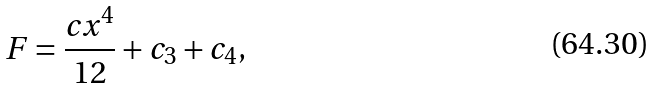Convert formula to latex. <formula><loc_0><loc_0><loc_500><loc_500>F = \frac { c x ^ { 4 } } { 1 2 } + c _ { 3 } + c _ { 4 } ,</formula> 